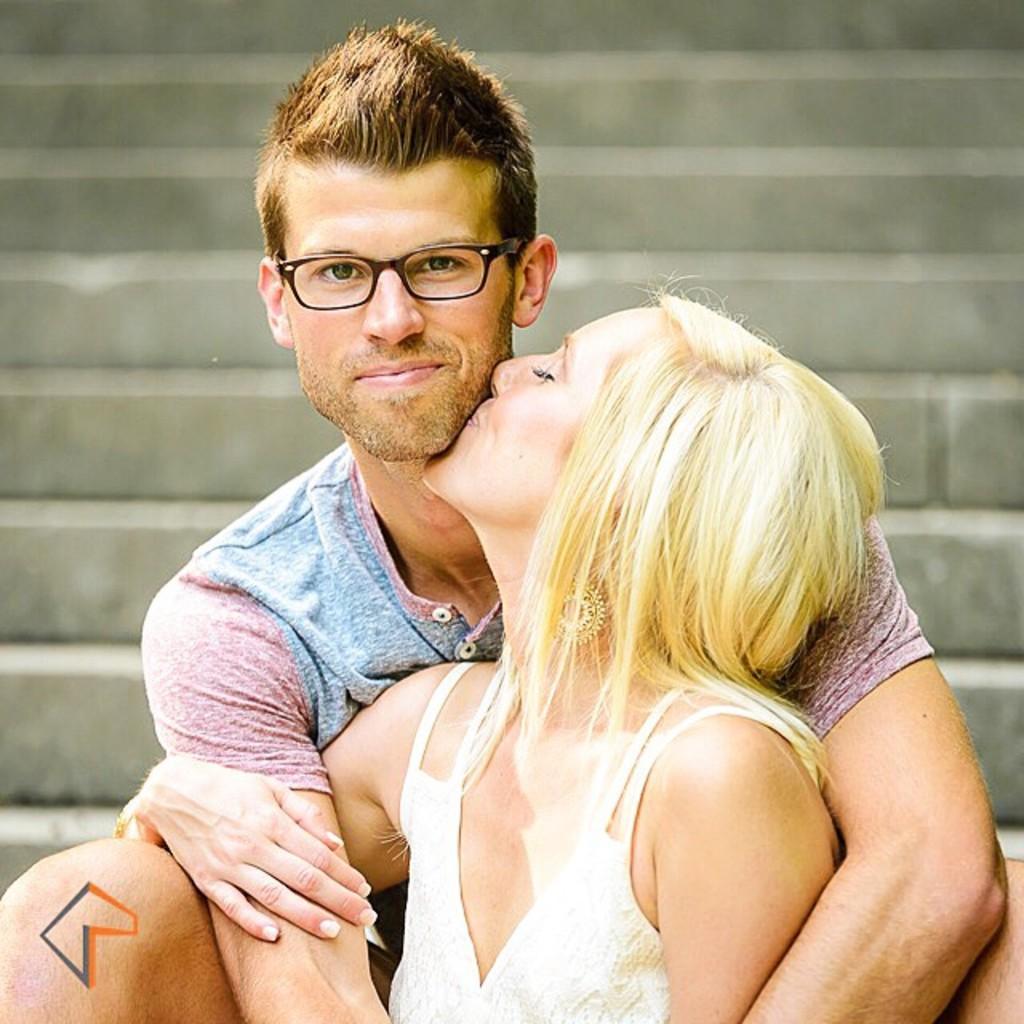In one or two sentences, can you explain what this image depicts? In this image we can see a woman kissing the man who is smiling and wearing the glasses. In the background we can see the stairs. 